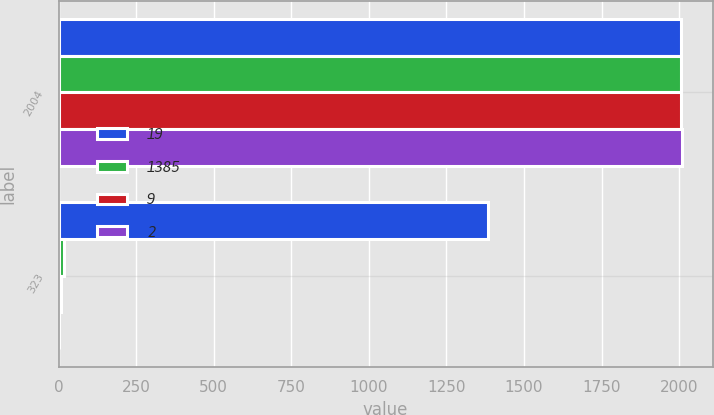Convert chart to OTSL. <chart><loc_0><loc_0><loc_500><loc_500><stacked_bar_chart><ecel><fcel>2004<fcel>323<nl><fcel>19<fcel>2005<fcel>1385<nl><fcel>1385<fcel>2006<fcel>19<nl><fcel>9<fcel>2007<fcel>9<nl><fcel>2<fcel>2008<fcel>2<nl></chart> 